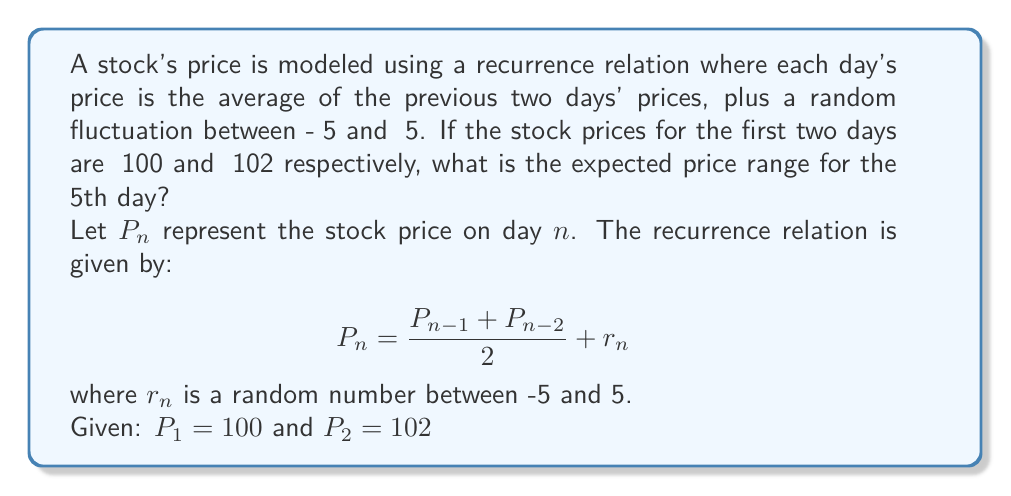Give your solution to this math problem. To solve this problem, we need to calculate the expected price for days 3, 4, and 5, considering the maximum possible fluctuations.

1. For day 3:
   $$P_3 = \frac{P_2 + P_1}{2} + r_3 = \frac{102 + 100}{2} + r_3 = 101 + r_3$$
   Minimum: $101 - 5 = 96$
   Maximum: $101 + 5 = 106$

2. For day 4:
   $$P_4 = \frac{P_3 + P_2}{2} + r_4$$
   Minimum: $\frac{96 + 102}{2} - 5 = 94$
   Maximum: $\frac{106 + 102}{2} + 5 = 109$

3. For day 5:
   $$P_5 = \frac{P_4 + P_3}{2} + r_5$$
   Minimum: $\frac{94 + 96}{2} - 5 = 90$
   Maximum: $\frac{109 + 106}{2} + 5 = 112.5$

Therefore, the expected price range for the 5th day is between ₹90 and ₹112.5.
Answer: The expected price range for the 5th day is ₹90 to ₹112.5. 